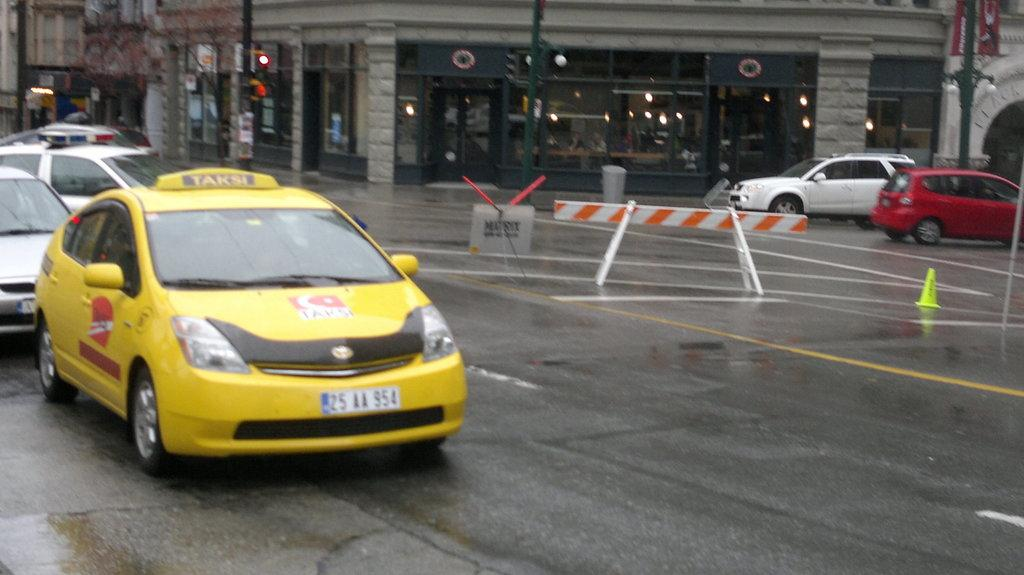What is covering the road in the image? There is water on the road in the image. What is happening on the road in the image? Vehicles are moving on the road in the image. What can be seen in the distance in the image? There are buildings visible in the background of the image. What type of dress is being worn by the appliance in the image? There is no dress or appliance present in the image. 